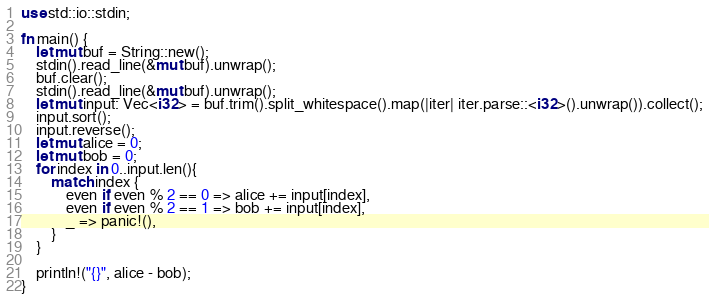<code> <loc_0><loc_0><loc_500><loc_500><_Rust_>use std::io::stdin;

fn main() {
    let mut buf = String::new();
    stdin().read_line(&mut buf).unwrap();
    buf.clear();
    stdin().read_line(&mut buf).unwrap();
    let mut input: Vec<i32> = buf.trim().split_whitespace().map(|iter| iter.parse::<i32>().unwrap()).collect();
    input.sort();
    input.reverse();
    let mut alice = 0;
    let mut bob = 0;
    for index in 0..input.len(){
        match index {
            even if even % 2 == 0 => alice += input[index],
            even if even % 2 == 1 => bob += input[index],
            _ => panic!(),
        }
    }

    println!("{}", alice - bob);
}
</code> 